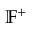<formula> <loc_0><loc_0><loc_500><loc_500>\mathbb { F } ^ { + }</formula> 